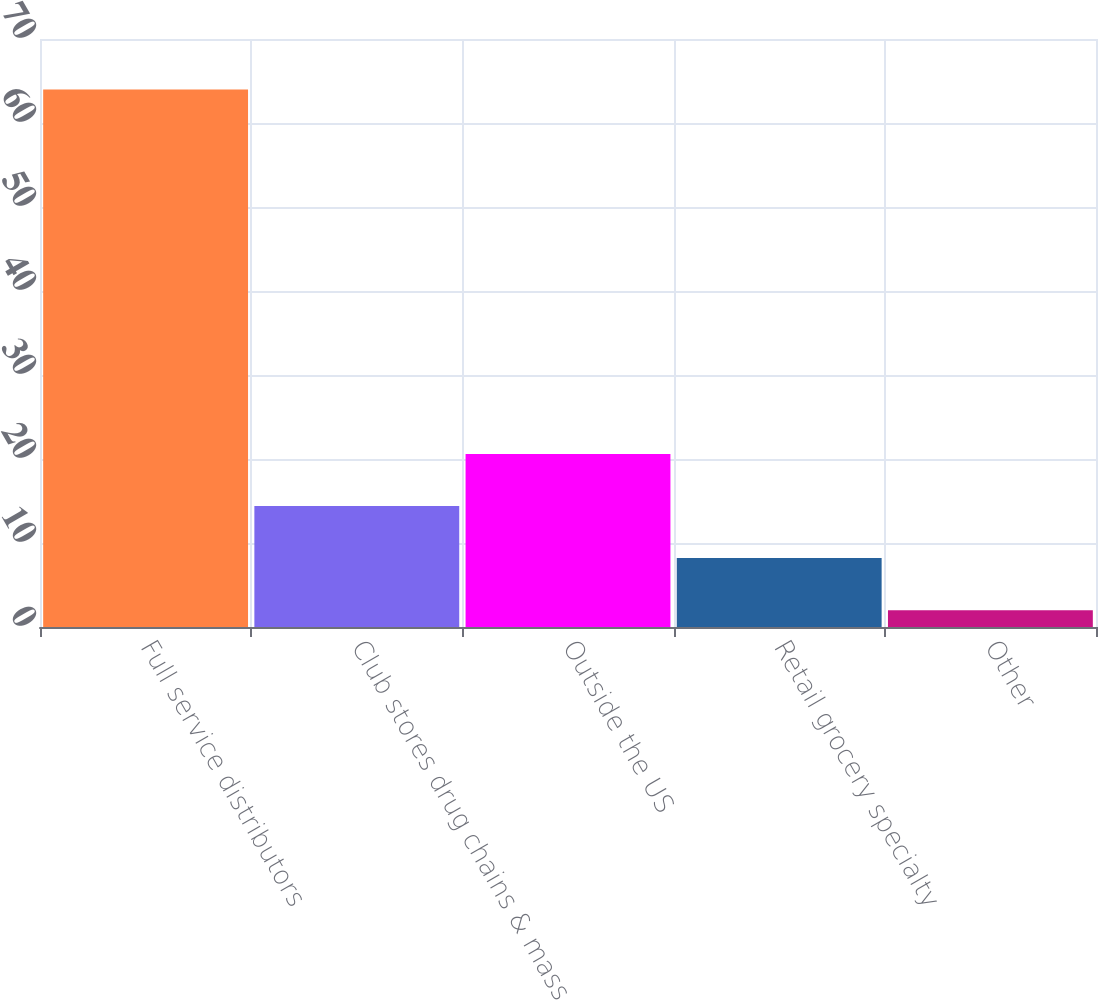Convert chart. <chart><loc_0><loc_0><loc_500><loc_500><bar_chart><fcel>Full service distributors<fcel>Club stores drug chains & mass<fcel>Outside the US<fcel>Retail grocery specialty<fcel>Other<nl><fcel>64<fcel>14.4<fcel>20.6<fcel>8.2<fcel>2<nl></chart> 